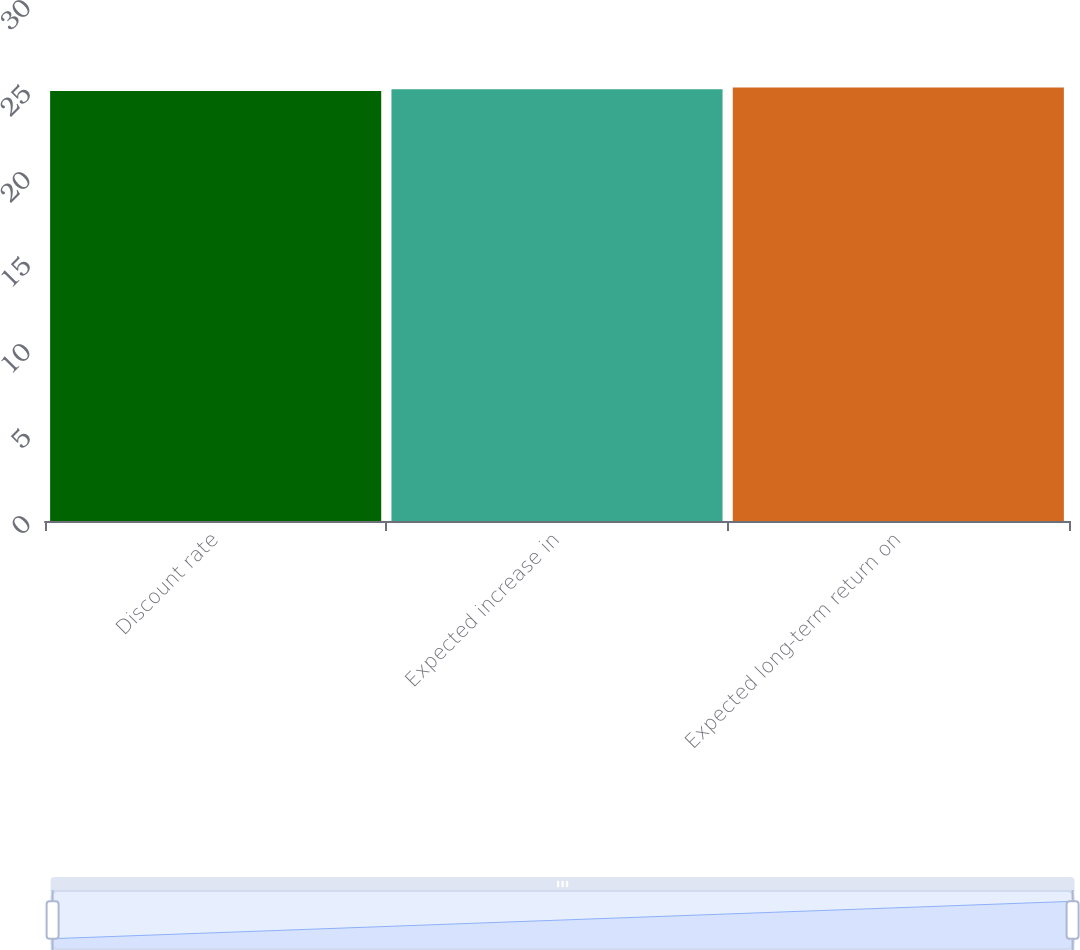Convert chart to OTSL. <chart><loc_0><loc_0><loc_500><loc_500><bar_chart><fcel>Discount rate<fcel>Expected increase in<fcel>Expected long-term return on<nl><fcel>25<fcel>25.1<fcel>25.2<nl></chart> 